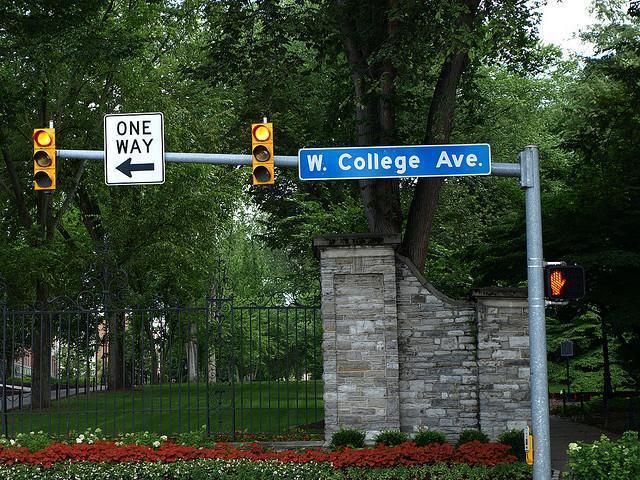How many giraffes are inside the building?
Give a very brief answer. 0. 